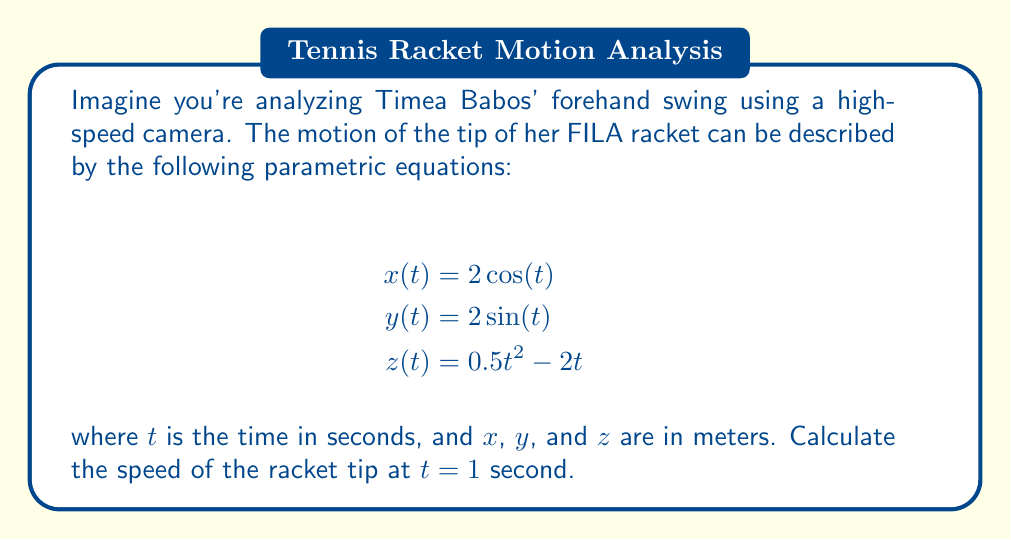Provide a solution to this math problem. To solve this problem, we need to follow these steps:

1) The speed of an object moving in three dimensions is given by the magnitude of its velocity vector. The velocity vector is the first derivative of the position vector with respect to time.

2) Let's find the velocity components by differentiating each parametric equation:

   $$\frac{dx}{dt} = -2\sin(t)$$
   $$\frac{dy}{dt} = 2\cos(t)$$
   $$\frac{dz}{dt} = t - 2$$

3) The velocity vector at any time $t$ is:

   $$\vec{v}(t) = \left(-2\sin(t), 2\cos(t), t-2\right)$$

4) The speed is the magnitude of this vector:

   $$\text{speed} = \sqrt{\left(\frac{dx}{dt}\right)^2 + \left(\frac{dy}{dt}\right)^2 + \left(\frac{dz}{dt}\right)^2}$$

5) Substituting $t = 1$ into our velocity components:

   $$\frac{dx}{dt}(1) = -2\sin(1)$$
   $$\frac{dy}{dt}(1) = 2\cos(1)$$
   $$\frac{dz}{dt}(1) = 1 - 2 = -1$$

6) Now we can calculate the speed:

   $$\text{speed} = \sqrt{(-2\sin(1))^2 + (2\cos(1))^2 + (-1)^2}$$

7) Simplify:
   
   $$\text{speed} = \sqrt{4\sin^2(1) + 4\cos^2(1) + 1}$$
   $$= \sqrt{4(\sin^2(1) + \cos^2(1)) + 1}$$
   $$= \sqrt{4 \cdot 1 + 1} = \sqrt{5}$$

Therefore, the speed of the racket tip at $t = 1$ second is $\sqrt{5}$ meters per second.
Answer: $\sqrt{5}$ m/s 